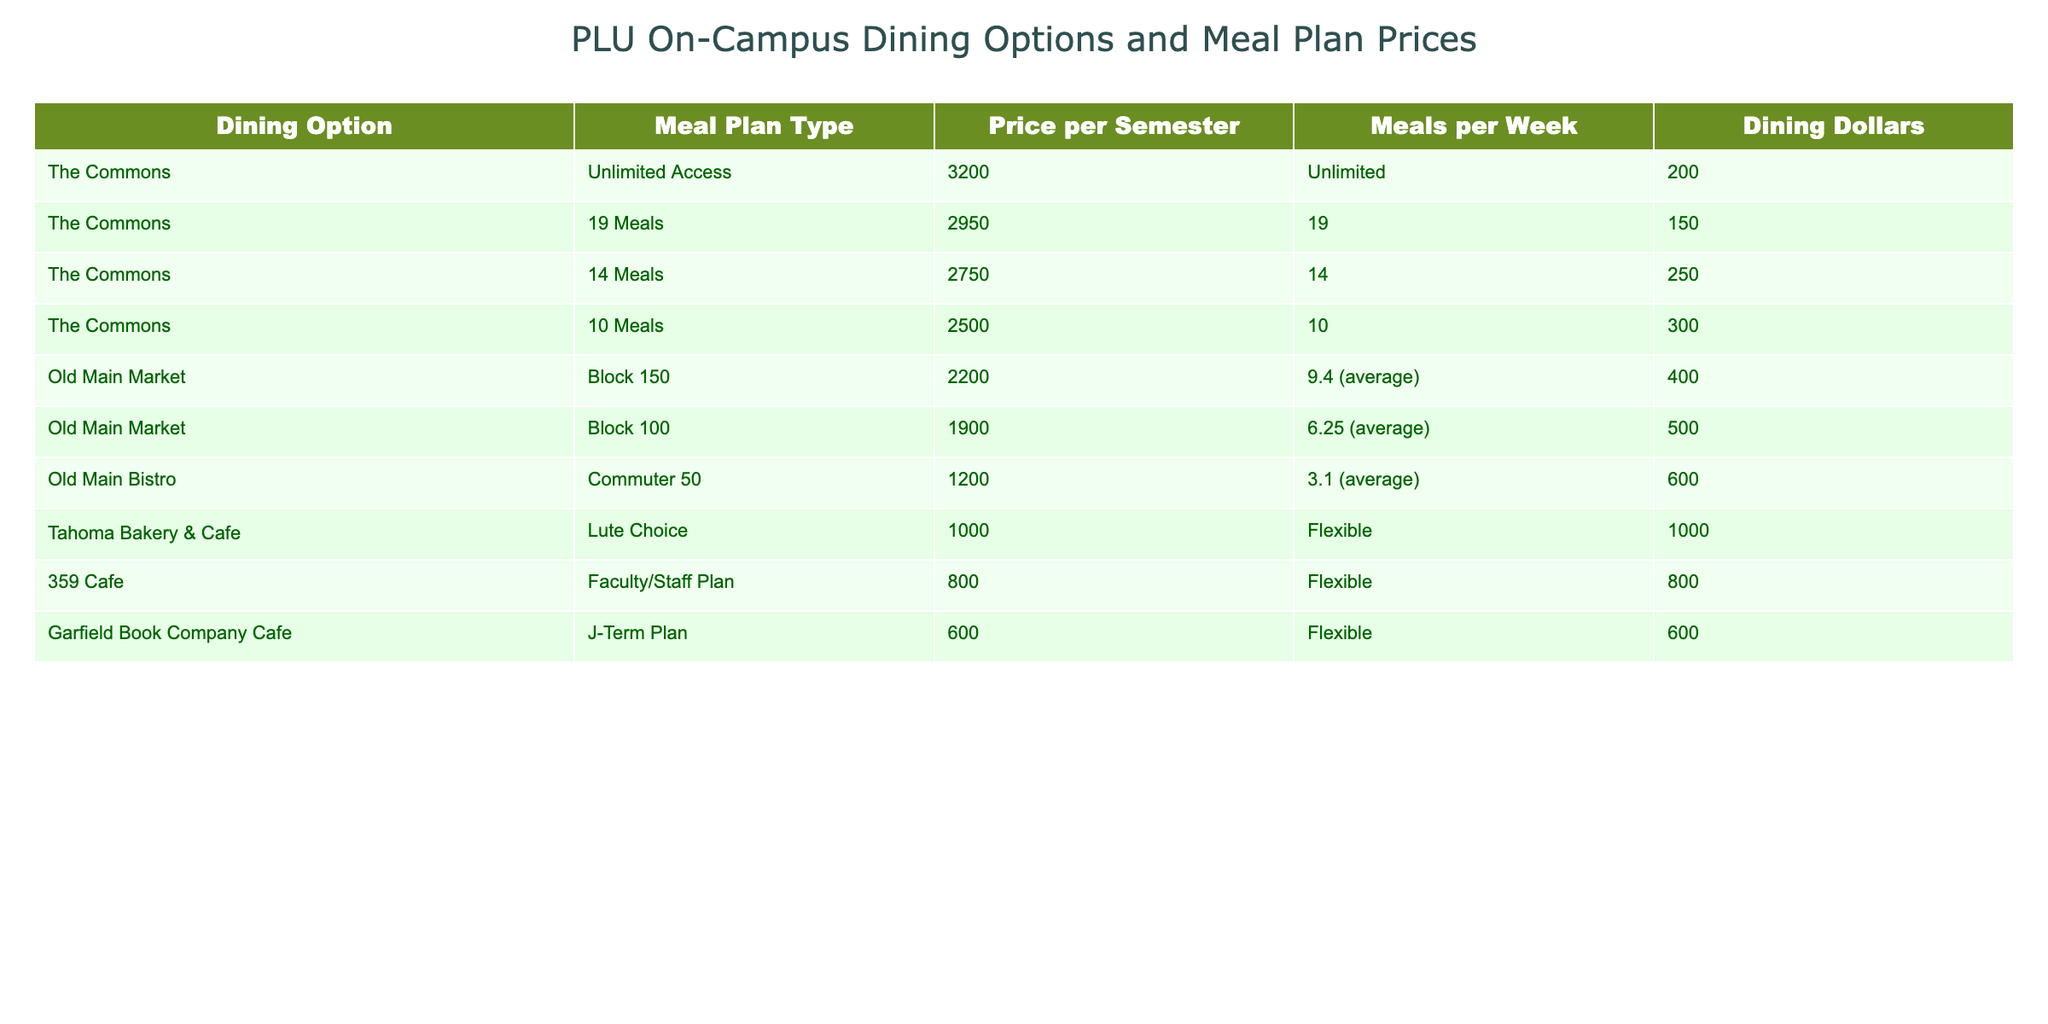What is the most expensive meal plan available at PLU? The table lists all meal plans with their respective prices. The plan with the highest price is the "Unlimited Access" meal plan at The Commons, priced at $3200 per semester.
Answer: $3200 How many dining dollars are included with the 14 Meals plan? The table provides the meal plan types along with their dining dollars. The "14 Meals" plan at The Commons includes 250 dining dollars.
Answer: 250 If a student chooses the Block 100 plan, how many meals are they allowed per week? The table indicates that the "Block 100" meal plan allows for approximately 6.25 meals per week.
Answer: 6.25 What is the total cost difference between the Unlimited Access plan and the 19 Meals plan? Calculate the difference by subtracting the price of the 19 Meals plan ($2950) from the price of the Unlimited Access plan ($3200): $3200 - $2950 = $250.
Answer: $250 Does the Tahoma Bakery & Cafe offer a meal plan that includes flexible meals? The table shows that the Tahoma Bakery & Cafe offers the "Lute Choice" meal plan, which is labeled as flexible, confirming that it does indeed offer a flexible meal plan.
Answer: Yes What plan gives the most dining dollars per semester? The table shows that the "Lute Choice" plan at Tahoma Bakery & Cafe includes 1000 dining dollars, which is more than any other plan. Therefore, it offers the most dining dollars.
Answer: 1000 If a student wants to have 10 meals per week and use fewer dining dollars, which plan should they consider? The table shows the "10 Meals" plan that allows for 10 meals per week while providing 300 dining dollars, which is a suitable option for this requirement.
Answer: 10 Meals plan What is the average price of the meal plans offered at The Commons? To find the average price, sum the prices for all meal plans at The Commons ($3200 + $2950 + $2750 + $2500) = $11400, then divide by the number of plans (4): $11400 / 4 = $2850.
Answer: $2850 How does the price of the Commuter 50 plan compare to the Faculty/Staff Plan? The "Commuter 50" plan costs $1200, while the "Faculty/Staff Plan" costs $800. The Commuter 50 plan is more expensive by $400. Calculation: $1200 - $800 = $400.
Answer: $400 Which dining option has the least expensive meal plan? Upon reviewing the table, the least expensive meal plan is the "J-Term Plan" from the Garfield Book Company Cafe at a cost of $600.
Answer: $600 